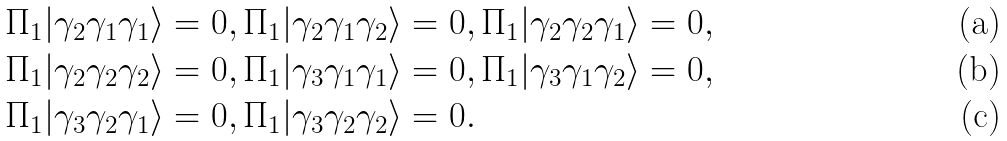Convert formula to latex. <formula><loc_0><loc_0><loc_500><loc_500>& \Pi _ { 1 } | \gamma _ { 2 } \gamma _ { 1 } \gamma _ { 1 } \rangle = 0 , \Pi _ { 1 } | \gamma _ { 2 } \gamma _ { 1 } \gamma _ { 2 } \rangle = 0 , \Pi _ { 1 } | \gamma _ { 2 } \gamma _ { 2 } \gamma _ { 1 } \rangle = 0 , \\ & \Pi _ { 1 } | \gamma _ { 2 } \gamma _ { 2 } \gamma _ { 2 } \rangle = 0 , \Pi _ { 1 } | \gamma _ { 3 } \gamma _ { 1 } \gamma _ { 1 } \rangle = 0 , \Pi _ { 1 } | \gamma _ { 3 } \gamma _ { 1 } \gamma _ { 2 } \rangle = 0 , \\ & \Pi _ { 1 } | \gamma _ { 3 } \gamma _ { 2 } \gamma _ { 1 } \rangle = 0 , \Pi _ { 1 } | \gamma _ { 3 } \gamma _ { 2 } \gamma _ { 2 } \rangle = 0 .</formula> 